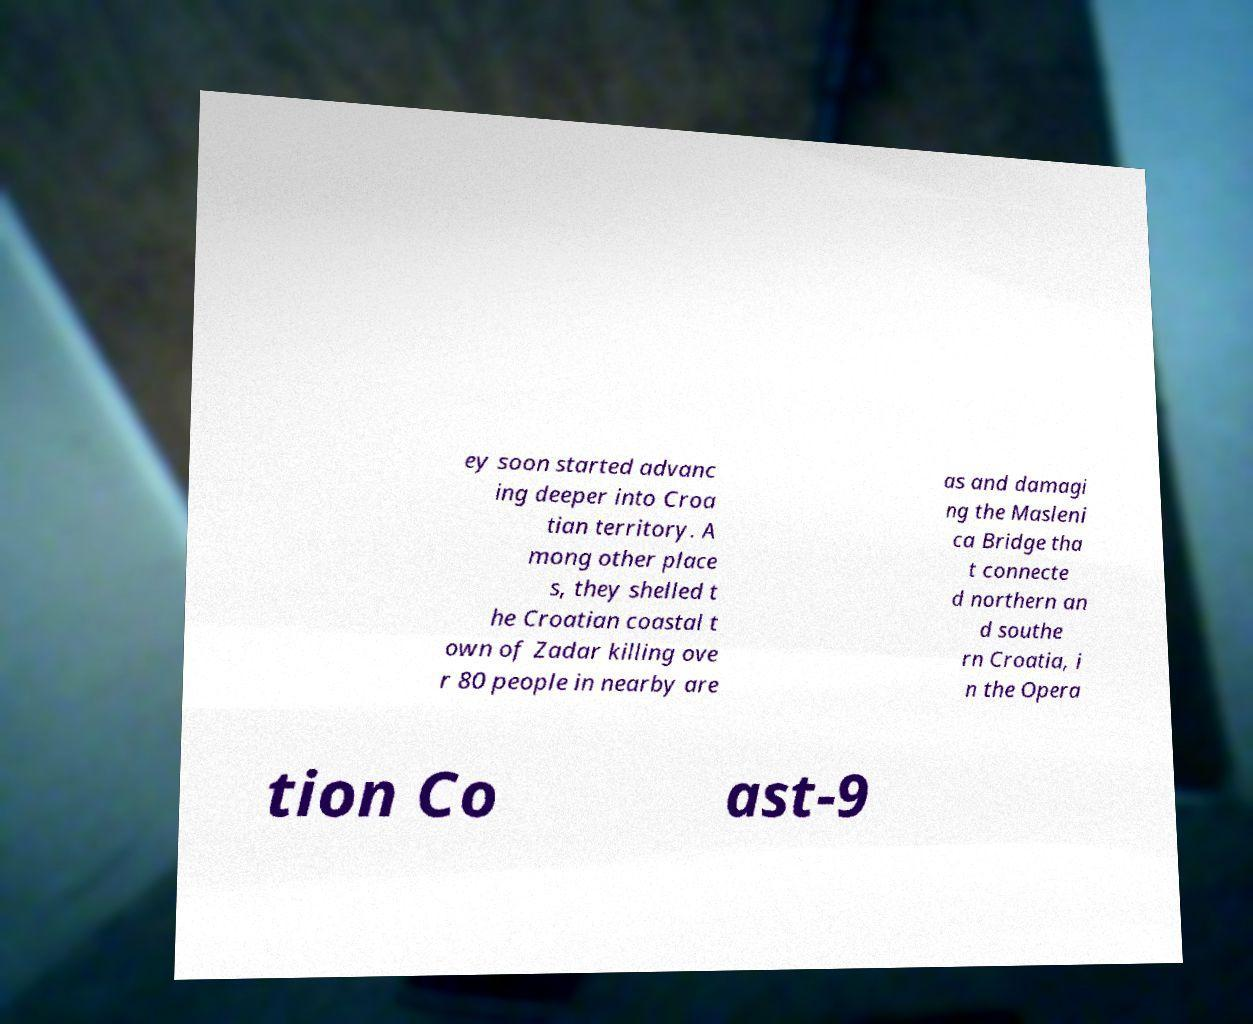Could you assist in decoding the text presented in this image and type it out clearly? ey soon started advanc ing deeper into Croa tian territory. A mong other place s, they shelled t he Croatian coastal t own of Zadar killing ove r 80 people in nearby are as and damagi ng the Masleni ca Bridge tha t connecte d northern an d southe rn Croatia, i n the Opera tion Co ast-9 